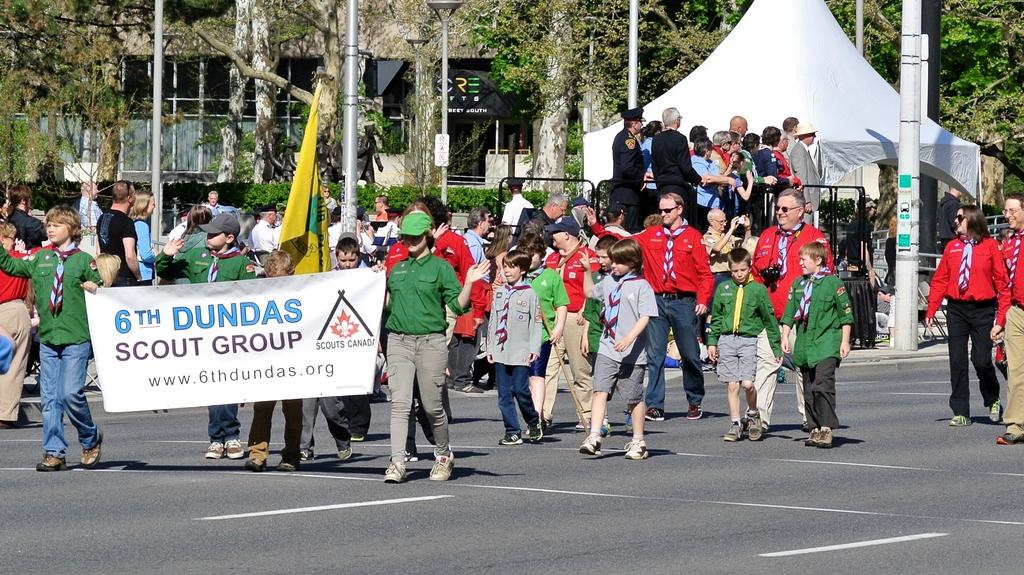How many people are in the group visible in the image? There is a group of people in the image, but the exact number cannot be determined from the provided facts. What can be seen flying in the image? There is a flag in the image. What is hanging in the image besides the flag? There is a banner in the image. What type of natural environment is visible in the image? There are trees in the image, indicating a natural environment. What type of man-made structures are visible in the image? There are buildings in the image. What type of current is flowing through the cabbage in the image? There is no cabbage present in the image, and therefore no current can be flowing through it. 